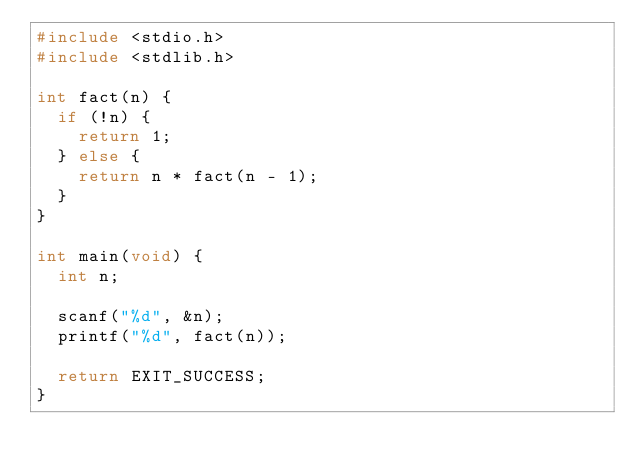Convert code to text. <code><loc_0><loc_0><loc_500><loc_500><_C_>#include <stdio.h>
#include <stdlib.h>

int fact(n) {
  if (!n) {
    return 1;
  } else {
    return n * fact(n - 1);
  }
}

int main(void) {
  int n;

  scanf("%d", &n);
  printf("%d", fact(n));

  return EXIT_SUCCESS;
}</code> 